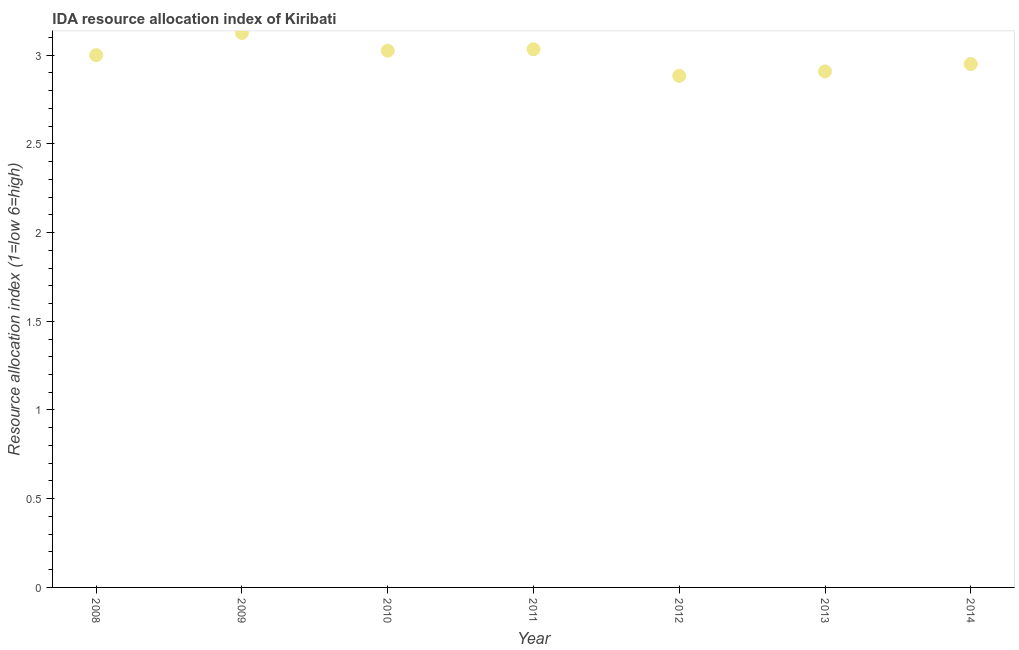What is the ida resource allocation index in 2009?
Provide a short and direct response. 3.12. Across all years, what is the maximum ida resource allocation index?
Keep it short and to the point. 3.12. Across all years, what is the minimum ida resource allocation index?
Provide a succinct answer. 2.88. What is the sum of the ida resource allocation index?
Offer a very short reply. 20.92. What is the difference between the ida resource allocation index in 2009 and 2011?
Offer a terse response. 0.09. What is the average ida resource allocation index per year?
Ensure brevity in your answer.  2.99. What is the ratio of the ida resource allocation index in 2013 to that in 2014?
Provide a short and direct response. 0.99. Is the ida resource allocation index in 2008 less than that in 2011?
Make the answer very short. Yes. Is the difference between the ida resource allocation index in 2008 and 2012 greater than the difference between any two years?
Give a very brief answer. No. What is the difference between the highest and the second highest ida resource allocation index?
Your answer should be compact. 0.09. Is the sum of the ida resource allocation index in 2008 and 2014 greater than the maximum ida resource allocation index across all years?
Provide a short and direct response. Yes. What is the difference between the highest and the lowest ida resource allocation index?
Make the answer very short. 0.24. In how many years, is the ida resource allocation index greater than the average ida resource allocation index taken over all years?
Give a very brief answer. 4. Does the ida resource allocation index monotonically increase over the years?
Give a very brief answer. No. How many dotlines are there?
Make the answer very short. 1. Are the values on the major ticks of Y-axis written in scientific E-notation?
Your answer should be compact. No. What is the title of the graph?
Offer a very short reply. IDA resource allocation index of Kiribati. What is the label or title of the Y-axis?
Offer a very short reply. Resource allocation index (1=low 6=high). What is the Resource allocation index (1=low 6=high) in 2009?
Your answer should be very brief. 3.12. What is the Resource allocation index (1=low 6=high) in 2010?
Your response must be concise. 3.02. What is the Resource allocation index (1=low 6=high) in 2011?
Provide a succinct answer. 3.03. What is the Resource allocation index (1=low 6=high) in 2012?
Your answer should be compact. 2.88. What is the Resource allocation index (1=low 6=high) in 2013?
Make the answer very short. 2.91. What is the Resource allocation index (1=low 6=high) in 2014?
Your response must be concise. 2.95. What is the difference between the Resource allocation index (1=low 6=high) in 2008 and 2009?
Your response must be concise. -0.12. What is the difference between the Resource allocation index (1=low 6=high) in 2008 and 2010?
Your response must be concise. -0.03. What is the difference between the Resource allocation index (1=low 6=high) in 2008 and 2011?
Your response must be concise. -0.03. What is the difference between the Resource allocation index (1=low 6=high) in 2008 and 2012?
Keep it short and to the point. 0.12. What is the difference between the Resource allocation index (1=low 6=high) in 2008 and 2013?
Provide a succinct answer. 0.09. What is the difference between the Resource allocation index (1=low 6=high) in 2008 and 2014?
Ensure brevity in your answer.  0.05. What is the difference between the Resource allocation index (1=low 6=high) in 2009 and 2011?
Your answer should be very brief. 0.09. What is the difference between the Resource allocation index (1=low 6=high) in 2009 and 2012?
Give a very brief answer. 0.24. What is the difference between the Resource allocation index (1=low 6=high) in 2009 and 2013?
Ensure brevity in your answer.  0.22. What is the difference between the Resource allocation index (1=low 6=high) in 2009 and 2014?
Give a very brief answer. 0.17. What is the difference between the Resource allocation index (1=low 6=high) in 2010 and 2011?
Make the answer very short. -0.01. What is the difference between the Resource allocation index (1=low 6=high) in 2010 and 2012?
Your answer should be compact. 0.14. What is the difference between the Resource allocation index (1=low 6=high) in 2010 and 2013?
Make the answer very short. 0.12. What is the difference between the Resource allocation index (1=low 6=high) in 2010 and 2014?
Give a very brief answer. 0.07. What is the difference between the Resource allocation index (1=low 6=high) in 2011 and 2013?
Offer a terse response. 0.12. What is the difference between the Resource allocation index (1=low 6=high) in 2011 and 2014?
Your answer should be compact. 0.08. What is the difference between the Resource allocation index (1=low 6=high) in 2012 and 2013?
Ensure brevity in your answer.  -0.03. What is the difference between the Resource allocation index (1=low 6=high) in 2012 and 2014?
Ensure brevity in your answer.  -0.07. What is the difference between the Resource allocation index (1=low 6=high) in 2013 and 2014?
Ensure brevity in your answer.  -0.04. What is the ratio of the Resource allocation index (1=low 6=high) in 2008 to that in 2011?
Give a very brief answer. 0.99. What is the ratio of the Resource allocation index (1=low 6=high) in 2008 to that in 2013?
Give a very brief answer. 1.03. What is the ratio of the Resource allocation index (1=low 6=high) in 2008 to that in 2014?
Offer a very short reply. 1.02. What is the ratio of the Resource allocation index (1=low 6=high) in 2009 to that in 2010?
Provide a succinct answer. 1.03. What is the ratio of the Resource allocation index (1=low 6=high) in 2009 to that in 2012?
Provide a succinct answer. 1.08. What is the ratio of the Resource allocation index (1=low 6=high) in 2009 to that in 2013?
Provide a succinct answer. 1.07. What is the ratio of the Resource allocation index (1=low 6=high) in 2009 to that in 2014?
Your response must be concise. 1.06. What is the ratio of the Resource allocation index (1=low 6=high) in 2010 to that in 2012?
Provide a succinct answer. 1.05. What is the ratio of the Resource allocation index (1=low 6=high) in 2011 to that in 2012?
Your answer should be compact. 1.05. What is the ratio of the Resource allocation index (1=low 6=high) in 2011 to that in 2013?
Keep it short and to the point. 1.04. What is the ratio of the Resource allocation index (1=low 6=high) in 2011 to that in 2014?
Offer a terse response. 1.03. What is the ratio of the Resource allocation index (1=low 6=high) in 2012 to that in 2013?
Keep it short and to the point. 0.99. What is the ratio of the Resource allocation index (1=low 6=high) in 2013 to that in 2014?
Provide a succinct answer. 0.99. 